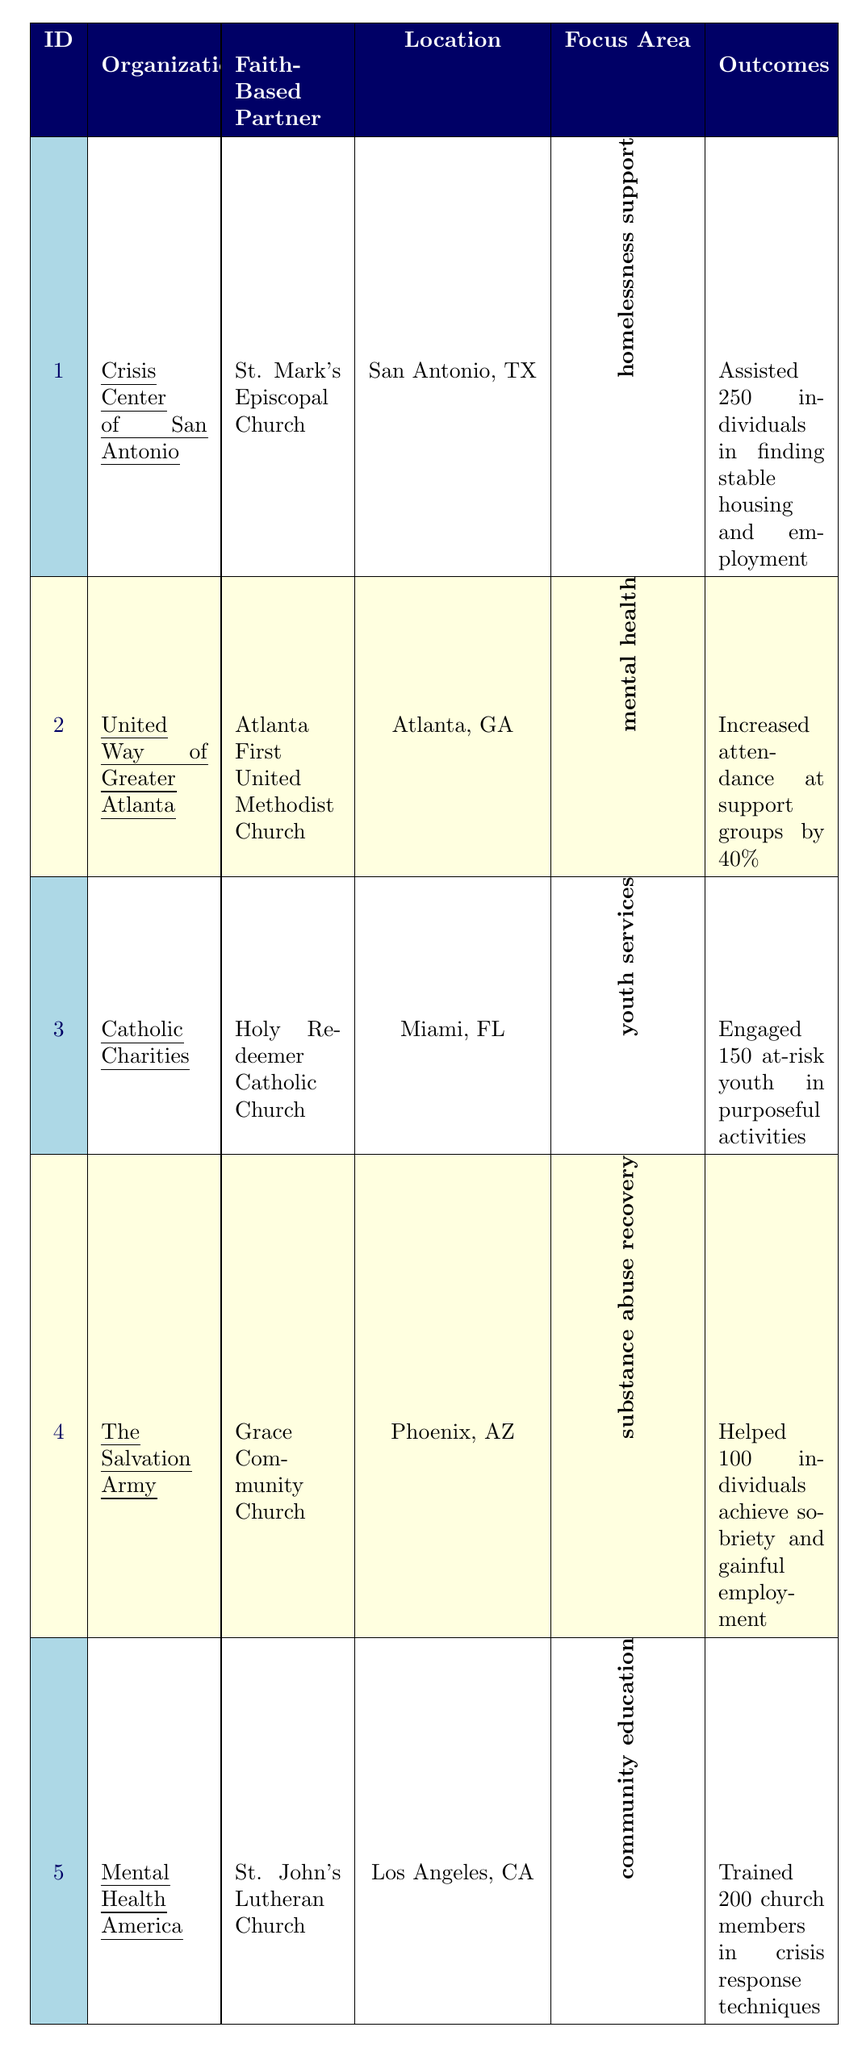What is the focus area of the Crisis Center of San Antonio's initiative? The table shows that the focus area for the Crisis Center of San Antonio is homelessness support.
Answer: homelessness support Which organization partnered with St. John's Lutheran Church? According to the table, Mental Health America is the organization that partnered with St. John's Lutheran Church.
Answer: Mental Health America How many individuals did The Salvation Army help achieve sobriety and gainful employment? The outcomes column indicates that The Salvation Army helped 100 individuals achieve sobriety and gainful employment.
Answer: 100 Which initiative had the highest number of individuals assisted in a measurable outcome? The table lists that the Crisis Center of San Antonio assisted 250 individuals in finding stable housing and employment, which is the highest number compared to the others.
Answer: 250 Did Catholic Charities engage more than 150 at-risk youth in purposeful activities? The table states that Catholic Charities engaged exactly 150 at-risk youth, which means they did not engage more than that number.
Answer: No What is the average number of individuals assisted across all initiatives? To find the average, sum the number of individuals assisted: 250 + 40 (from United Way) + 150 + 100 + 200 = 740. Then divide by the total initiatives (5): 740 / 5 = 148.
Answer: 148 Which city has a faith-based organization focused on community education? The table shows that Los Angeles, CA has Mental Health America, which focuses on community education through partnering with St. John's Lutheran Church.
Answer: Los Angeles, CA What was the primary service offered by United Way of Greater Atlanta's initiative? The table indicates that the primary services offered by United Way of Greater Atlanta included mental health workshops, family counseling, and faith integration.
Answer: mental health workshops, family counseling, faith integration Was there an initiative that focused specifically on substance abuse recovery? Yes, The Salvation Army's initiative specifically focused on substance abuse recovery, according to the focus area listed in the table.
Answer: Yes How many church members were trained in crisis response techniques by Mental Health America? The outcomes show that Mental Health America trained 200 church members in crisis response techniques.
Answer: 200 